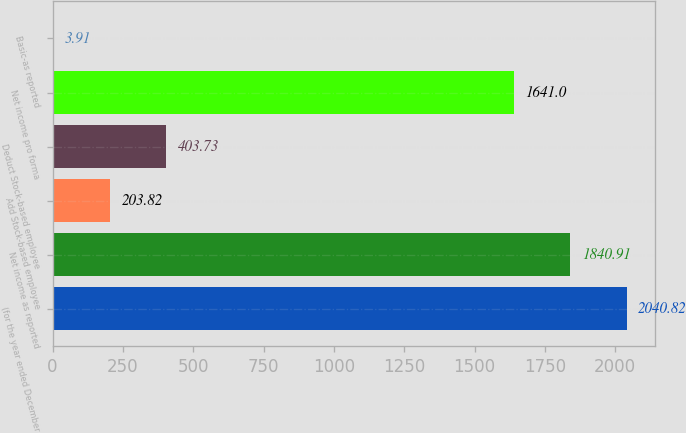<chart> <loc_0><loc_0><loc_500><loc_500><bar_chart><fcel>(for the year ended December<fcel>Net income as reported<fcel>Add Stock-based employee<fcel>Deduct Stock-based employee<fcel>Net income pro forma<fcel>Basic-as reported<nl><fcel>2040.82<fcel>1840.91<fcel>203.82<fcel>403.73<fcel>1641<fcel>3.91<nl></chart> 